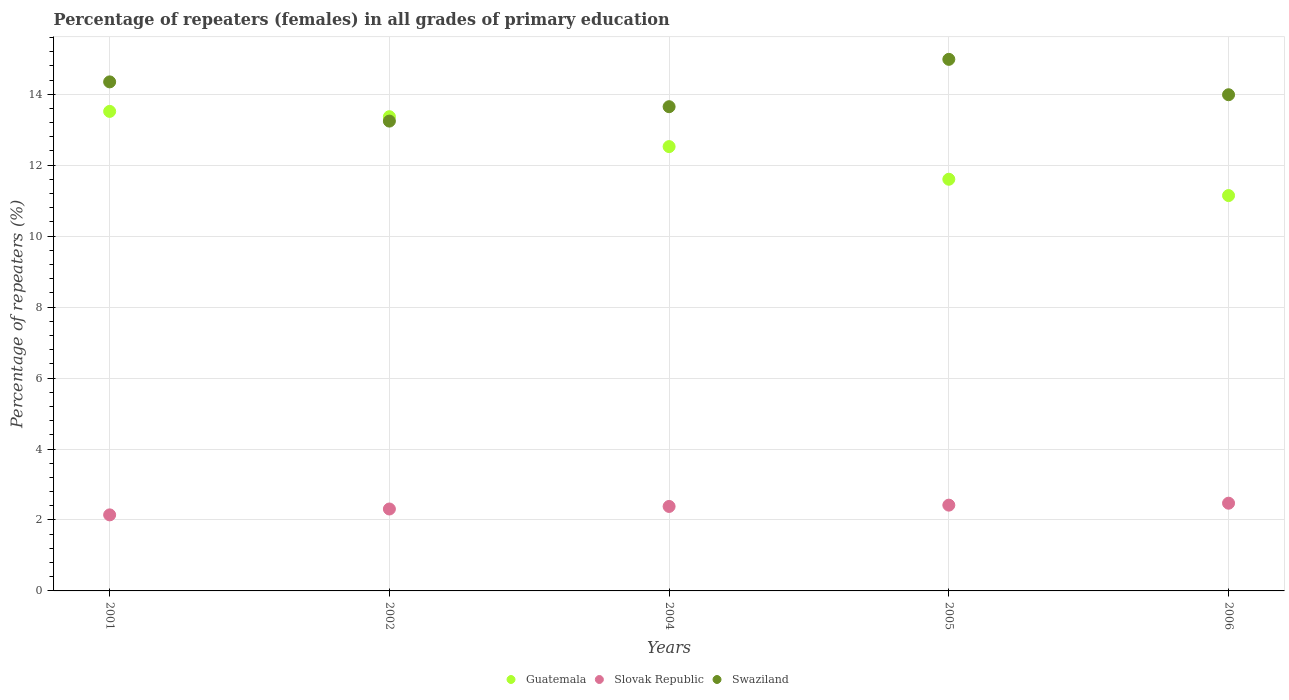How many different coloured dotlines are there?
Your answer should be very brief. 3. Is the number of dotlines equal to the number of legend labels?
Give a very brief answer. Yes. What is the percentage of repeaters (females) in Slovak Republic in 2004?
Provide a short and direct response. 2.38. Across all years, what is the maximum percentage of repeaters (females) in Swaziland?
Ensure brevity in your answer.  14.98. Across all years, what is the minimum percentage of repeaters (females) in Swaziland?
Provide a succinct answer. 13.24. In which year was the percentage of repeaters (females) in Guatemala maximum?
Offer a very short reply. 2001. In which year was the percentage of repeaters (females) in Guatemala minimum?
Make the answer very short. 2006. What is the total percentage of repeaters (females) in Swaziland in the graph?
Give a very brief answer. 70.21. What is the difference between the percentage of repeaters (females) in Swaziland in 2001 and that in 2006?
Offer a very short reply. 0.36. What is the difference between the percentage of repeaters (females) in Swaziland in 2006 and the percentage of repeaters (females) in Guatemala in 2002?
Ensure brevity in your answer.  0.62. What is the average percentage of repeaters (females) in Swaziland per year?
Give a very brief answer. 14.04. In the year 2004, what is the difference between the percentage of repeaters (females) in Swaziland and percentage of repeaters (females) in Slovak Republic?
Offer a terse response. 11.27. In how many years, is the percentage of repeaters (females) in Swaziland greater than 6.4 %?
Make the answer very short. 5. What is the ratio of the percentage of repeaters (females) in Slovak Republic in 2002 to that in 2005?
Give a very brief answer. 0.96. Is the percentage of repeaters (females) in Swaziland in 2002 less than that in 2006?
Your answer should be compact. Yes. What is the difference between the highest and the second highest percentage of repeaters (females) in Slovak Republic?
Provide a short and direct response. 0.05. What is the difference between the highest and the lowest percentage of repeaters (females) in Swaziland?
Offer a terse response. 1.74. In how many years, is the percentage of repeaters (females) in Guatemala greater than the average percentage of repeaters (females) in Guatemala taken over all years?
Offer a very short reply. 3. Is the sum of the percentage of repeaters (females) in Slovak Republic in 2001 and 2004 greater than the maximum percentage of repeaters (females) in Guatemala across all years?
Your answer should be very brief. No. Is the percentage of repeaters (females) in Swaziland strictly less than the percentage of repeaters (females) in Guatemala over the years?
Offer a terse response. No. How many dotlines are there?
Offer a very short reply. 3. How many years are there in the graph?
Provide a short and direct response. 5. What is the difference between two consecutive major ticks on the Y-axis?
Offer a terse response. 2. Does the graph contain any zero values?
Offer a terse response. No. Does the graph contain grids?
Offer a terse response. Yes. What is the title of the graph?
Offer a terse response. Percentage of repeaters (females) in all grades of primary education. What is the label or title of the X-axis?
Give a very brief answer. Years. What is the label or title of the Y-axis?
Offer a terse response. Percentage of repeaters (%). What is the Percentage of repeaters (%) in Guatemala in 2001?
Keep it short and to the point. 13.52. What is the Percentage of repeaters (%) of Slovak Republic in 2001?
Keep it short and to the point. 2.14. What is the Percentage of repeaters (%) in Swaziland in 2001?
Your answer should be very brief. 14.35. What is the Percentage of repeaters (%) of Guatemala in 2002?
Make the answer very short. 13.37. What is the Percentage of repeaters (%) of Slovak Republic in 2002?
Your answer should be compact. 2.31. What is the Percentage of repeaters (%) in Swaziland in 2002?
Offer a very short reply. 13.24. What is the Percentage of repeaters (%) of Guatemala in 2004?
Make the answer very short. 12.52. What is the Percentage of repeaters (%) of Slovak Republic in 2004?
Give a very brief answer. 2.38. What is the Percentage of repeaters (%) of Swaziland in 2004?
Offer a very short reply. 13.65. What is the Percentage of repeaters (%) in Guatemala in 2005?
Make the answer very short. 11.6. What is the Percentage of repeaters (%) in Slovak Republic in 2005?
Provide a short and direct response. 2.42. What is the Percentage of repeaters (%) of Swaziland in 2005?
Keep it short and to the point. 14.98. What is the Percentage of repeaters (%) of Guatemala in 2006?
Make the answer very short. 11.14. What is the Percentage of repeaters (%) of Slovak Republic in 2006?
Keep it short and to the point. 2.47. What is the Percentage of repeaters (%) of Swaziland in 2006?
Give a very brief answer. 13.99. Across all years, what is the maximum Percentage of repeaters (%) of Guatemala?
Your answer should be compact. 13.52. Across all years, what is the maximum Percentage of repeaters (%) of Slovak Republic?
Give a very brief answer. 2.47. Across all years, what is the maximum Percentage of repeaters (%) in Swaziland?
Your answer should be very brief. 14.98. Across all years, what is the minimum Percentage of repeaters (%) of Guatemala?
Your answer should be very brief. 11.14. Across all years, what is the minimum Percentage of repeaters (%) of Slovak Republic?
Offer a very short reply. 2.14. Across all years, what is the minimum Percentage of repeaters (%) of Swaziland?
Your response must be concise. 13.24. What is the total Percentage of repeaters (%) of Guatemala in the graph?
Your answer should be very brief. 62.15. What is the total Percentage of repeaters (%) of Slovak Republic in the graph?
Give a very brief answer. 11.72. What is the total Percentage of repeaters (%) of Swaziland in the graph?
Your response must be concise. 70.21. What is the difference between the Percentage of repeaters (%) in Guatemala in 2001 and that in 2002?
Offer a very short reply. 0.15. What is the difference between the Percentage of repeaters (%) in Slovak Republic in 2001 and that in 2002?
Provide a succinct answer. -0.17. What is the difference between the Percentage of repeaters (%) of Swaziland in 2001 and that in 2002?
Keep it short and to the point. 1.11. What is the difference between the Percentage of repeaters (%) of Guatemala in 2001 and that in 2004?
Your response must be concise. 0.99. What is the difference between the Percentage of repeaters (%) of Slovak Republic in 2001 and that in 2004?
Your answer should be very brief. -0.24. What is the difference between the Percentage of repeaters (%) of Swaziland in 2001 and that in 2004?
Provide a short and direct response. 0.7. What is the difference between the Percentage of repeaters (%) in Guatemala in 2001 and that in 2005?
Offer a terse response. 1.91. What is the difference between the Percentage of repeaters (%) in Slovak Republic in 2001 and that in 2005?
Provide a succinct answer. -0.27. What is the difference between the Percentage of repeaters (%) in Swaziland in 2001 and that in 2005?
Your answer should be compact. -0.63. What is the difference between the Percentage of repeaters (%) in Guatemala in 2001 and that in 2006?
Your answer should be very brief. 2.37. What is the difference between the Percentage of repeaters (%) in Slovak Republic in 2001 and that in 2006?
Offer a terse response. -0.33. What is the difference between the Percentage of repeaters (%) in Swaziland in 2001 and that in 2006?
Your answer should be very brief. 0.36. What is the difference between the Percentage of repeaters (%) of Guatemala in 2002 and that in 2004?
Your response must be concise. 0.84. What is the difference between the Percentage of repeaters (%) of Slovak Republic in 2002 and that in 2004?
Offer a terse response. -0.07. What is the difference between the Percentage of repeaters (%) of Swaziland in 2002 and that in 2004?
Make the answer very short. -0.41. What is the difference between the Percentage of repeaters (%) of Guatemala in 2002 and that in 2005?
Offer a very short reply. 1.76. What is the difference between the Percentage of repeaters (%) of Slovak Republic in 2002 and that in 2005?
Offer a terse response. -0.11. What is the difference between the Percentage of repeaters (%) in Swaziland in 2002 and that in 2005?
Offer a very short reply. -1.74. What is the difference between the Percentage of repeaters (%) of Guatemala in 2002 and that in 2006?
Give a very brief answer. 2.22. What is the difference between the Percentage of repeaters (%) in Slovak Republic in 2002 and that in 2006?
Your answer should be very brief. -0.16. What is the difference between the Percentage of repeaters (%) of Swaziland in 2002 and that in 2006?
Provide a short and direct response. -0.74. What is the difference between the Percentage of repeaters (%) of Guatemala in 2004 and that in 2005?
Keep it short and to the point. 0.92. What is the difference between the Percentage of repeaters (%) in Slovak Republic in 2004 and that in 2005?
Ensure brevity in your answer.  -0.04. What is the difference between the Percentage of repeaters (%) of Swaziland in 2004 and that in 2005?
Give a very brief answer. -1.33. What is the difference between the Percentage of repeaters (%) in Guatemala in 2004 and that in 2006?
Ensure brevity in your answer.  1.38. What is the difference between the Percentage of repeaters (%) of Slovak Republic in 2004 and that in 2006?
Provide a short and direct response. -0.09. What is the difference between the Percentage of repeaters (%) in Swaziland in 2004 and that in 2006?
Make the answer very short. -0.34. What is the difference between the Percentage of repeaters (%) of Guatemala in 2005 and that in 2006?
Ensure brevity in your answer.  0.46. What is the difference between the Percentage of repeaters (%) of Slovak Republic in 2005 and that in 2006?
Your response must be concise. -0.05. What is the difference between the Percentage of repeaters (%) in Guatemala in 2001 and the Percentage of repeaters (%) in Slovak Republic in 2002?
Keep it short and to the point. 11.21. What is the difference between the Percentage of repeaters (%) of Guatemala in 2001 and the Percentage of repeaters (%) of Swaziland in 2002?
Offer a very short reply. 0.27. What is the difference between the Percentage of repeaters (%) in Slovak Republic in 2001 and the Percentage of repeaters (%) in Swaziland in 2002?
Make the answer very short. -11.1. What is the difference between the Percentage of repeaters (%) in Guatemala in 2001 and the Percentage of repeaters (%) in Slovak Republic in 2004?
Your response must be concise. 11.14. What is the difference between the Percentage of repeaters (%) in Guatemala in 2001 and the Percentage of repeaters (%) in Swaziland in 2004?
Offer a very short reply. -0.13. What is the difference between the Percentage of repeaters (%) in Slovak Republic in 2001 and the Percentage of repeaters (%) in Swaziland in 2004?
Ensure brevity in your answer.  -11.51. What is the difference between the Percentage of repeaters (%) in Guatemala in 2001 and the Percentage of repeaters (%) in Slovak Republic in 2005?
Give a very brief answer. 11.1. What is the difference between the Percentage of repeaters (%) of Guatemala in 2001 and the Percentage of repeaters (%) of Swaziland in 2005?
Provide a short and direct response. -1.47. What is the difference between the Percentage of repeaters (%) of Slovak Republic in 2001 and the Percentage of repeaters (%) of Swaziland in 2005?
Your answer should be compact. -12.84. What is the difference between the Percentage of repeaters (%) of Guatemala in 2001 and the Percentage of repeaters (%) of Slovak Republic in 2006?
Make the answer very short. 11.04. What is the difference between the Percentage of repeaters (%) of Guatemala in 2001 and the Percentage of repeaters (%) of Swaziland in 2006?
Offer a very short reply. -0.47. What is the difference between the Percentage of repeaters (%) of Slovak Republic in 2001 and the Percentage of repeaters (%) of Swaziland in 2006?
Provide a short and direct response. -11.84. What is the difference between the Percentage of repeaters (%) in Guatemala in 2002 and the Percentage of repeaters (%) in Slovak Republic in 2004?
Provide a succinct answer. 10.99. What is the difference between the Percentage of repeaters (%) in Guatemala in 2002 and the Percentage of repeaters (%) in Swaziland in 2004?
Provide a succinct answer. -0.28. What is the difference between the Percentage of repeaters (%) in Slovak Republic in 2002 and the Percentage of repeaters (%) in Swaziland in 2004?
Provide a short and direct response. -11.34. What is the difference between the Percentage of repeaters (%) in Guatemala in 2002 and the Percentage of repeaters (%) in Slovak Republic in 2005?
Offer a very short reply. 10.95. What is the difference between the Percentage of repeaters (%) of Guatemala in 2002 and the Percentage of repeaters (%) of Swaziland in 2005?
Make the answer very short. -1.62. What is the difference between the Percentage of repeaters (%) of Slovak Republic in 2002 and the Percentage of repeaters (%) of Swaziland in 2005?
Make the answer very short. -12.67. What is the difference between the Percentage of repeaters (%) in Guatemala in 2002 and the Percentage of repeaters (%) in Slovak Republic in 2006?
Your answer should be compact. 10.89. What is the difference between the Percentage of repeaters (%) in Guatemala in 2002 and the Percentage of repeaters (%) in Swaziland in 2006?
Ensure brevity in your answer.  -0.62. What is the difference between the Percentage of repeaters (%) in Slovak Republic in 2002 and the Percentage of repeaters (%) in Swaziland in 2006?
Your response must be concise. -11.68. What is the difference between the Percentage of repeaters (%) of Guatemala in 2004 and the Percentage of repeaters (%) of Slovak Republic in 2005?
Provide a short and direct response. 10.11. What is the difference between the Percentage of repeaters (%) of Guatemala in 2004 and the Percentage of repeaters (%) of Swaziland in 2005?
Your response must be concise. -2.46. What is the difference between the Percentage of repeaters (%) in Slovak Republic in 2004 and the Percentage of repeaters (%) in Swaziland in 2005?
Provide a short and direct response. -12.6. What is the difference between the Percentage of repeaters (%) in Guatemala in 2004 and the Percentage of repeaters (%) in Slovak Republic in 2006?
Give a very brief answer. 10.05. What is the difference between the Percentage of repeaters (%) of Guatemala in 2004 and the Percentage of repeaters (%) of Swaziland in 2006?
Provide a short and direct response. -1.46. What is the difference between the Percentage of repeaters (%) in Slovak Republic in 2004 and the Percentage of repeaters (%) in Swaziland in 2006?
Provide a short and direct response. -11.6. What is the difference between the Percentage of repeaters (%) of Guatemala in 2005 and the Percentage of repeaters (%) of Slovak Republic in 2006?
Keep it short and to the point. 9.13. What is the difference between the Percentage of repeaters (%) in Guatemala in 2005 and the Percentage of repeaters (%) in Swaziland in 2006?
Provide a short and direct response. -2.38. What is the difference between the Percentage of repeaters (%) of Slovak Republic in 2005 and the Percentage of repeaters (%) of Swaziland in 2006?
Provide a succinct answer. -11.57. What is the average Percentage of repeaters (%) of Guatemala per year?
Provide a succinct answer. 12.43. What is the average Percentage of repeaters (%) of Slovak Republic per year?
Offer a very short reply. 2.34. What is the average Percentage of repeaters (%) in Swaziland per year?
Make the answer very short. 14.04. In the year 2001, what is the difference between the Percentage of repeaters (%) in Guatemala and Percentage of repeaters (%) in Slovak Republic?
Provide a short and direct response. 11.37. In the year 2001, what is the difference between the Percentage of repeaters (%) of Guatemala and Percentage of repeaters (%) of Swaziland?
Offer a very short reply. -0.83. In the year 2001, what is the difference between the Percentage of repeaters (%) in Slovak Republic and Percentage of repeaters (%) in Swaziland?
Offer a terse response. -12.2. In the year 2002, what is the difference between the Percentage of repeaters (%) in Guatemala and Percentage of repeaters (%) in Slovak Republic?
Provide a succinct answer. 11.06. In the year 2002, what is the difference between the Percentage of repeaters (%) of Guatemala and Percentage of repeaters (%) of Swaziland?
Your response must be concise. 0.12. In the year 2002, what is the difference between the Percentage of repeaters (%) of Slovak Republic and Percentage of repeaters (%) of Swaziland?
Your answer should be compact. -10.93. In the year 2004, what is the difference between the Percentage of repeaters (%) of Guatemala and Percentage of repeaters (%) of Slovak Republic?
Give a very brief answer. 10.14. In the year 2004, what is the difference between the Percentage of repeaters (%) in Guatemala and Percentage of repeaters (%) in Swaziland?
Provide a succinct answer. -1.12. In the year 2004, what is the difference between the Percentage of repeaters (%) in Slovak Republic and Percentage of repeaters (%) in Swaziland?
Keep it short and to the point. -11.27. In the year 2005, what is the difference between the Percentage of repeaters (%) in Guatemala and Percentage of repeaters (%) in Slovak Republic?
Provide a succinct answer. 9.19. In the year 2005, what is the difference between the Percentage of repeaters (%) in Guatemala and Percentage of repeaters (%) in Swaziland?
Keep it short and to the point. -3.38. In the year 2005, what is the difference between the Percentage of repeaters (%) of Slovak Republic and Percentage of repeaters (%) of Swaziland?
Ensure brevity in your answer.  -12.57. In the year 2006, what is the difference between the Percentage of repeaters (%) of Guatemala and Percentage of repeaters (%) of Slovak Republic?
Your response must be concise. 8.67. In the year 2006, what is the difference between the Percentage of repeaters (%) of Guatemala and Percentage of repeaters (%) of Swaziland?
Keep it short and to the point. -2.84. In the year 2006, what is the difference between the Percentage of repeaters (%) in Slovak Republic and Percentage of repeaters (%) in Swaziland?
Make the answer very short. -11.51. What is the ratio of the Percentage of repeaters (%) of Guatemala in 2001 to that in 2002?
Your answer should be compact. 1.01. What is the ratio of the Percentage of repeaters (%) of Slovak Republic in 2001 to that in 2002?
Offer a very short reply. 0.93. What is the ratio of the Percentage of repeaters (%) in Swaziland in 2001 to that in 2002?
Keep it short and to the point. 1.08. What is the ratio of the Percentage of repeaters (%) of Guatemala in 2001 to that in 2004?
Give a very brief answer. 1.08. What is the ratio of the Percentage of repeaters (%) of Slovak Republic in 2001 to that in 2004?
Make the answer very short. 0.9. What is the ratio of the Percentage of repeaters (%) in Swaziland in 2001 to that in 2004?
Your answer should be very brief. 1.05. What is the ratio of the Percentage of repeaters (%) in Guatemala in 2001 to that in 2005?
Keep it short and to the point. 1.16. What is the ratio of the Percentage of repeaters (%) in Slovak Republic in 2001 to that in 2005?
Keep it short and to the point. 0.89. What is the ratio of the Percentage of repeaters (%) of Swaziland in 2001 to that in 2005?
Keep it short and to the point. 0.96. What is the ratio of the Percentage of repeaters (%) of Guatemala in 2001 to that in 2006?
Provide a succinct answer. 1.21. What is the ratio of the Percentage of repeaters (%) in Slovak Republic in 2001 to that in 2006?
Your response must be concise. 0.87. What is the ratio of the Percentage of repeaters (%) of Swaziland in 2001 to that in 2006?
Your answer should be very brief. 1.03. What is the ratio of the Percentage of repeaters (%) of Guatemala in 2002 to that in 2004?
Give a very brief answer. 1.07. What is the ratio of the Percentage of repeaters (%) of Slovak Republic in 2002 to that in 2004?
Give a very brief answer. 0.97. What is the ratio of the Percentage of repeaters (%) in Swaziland in 2002 to that in 2004?
Your answer should be very brief. 0.97. What is the ratio of the Percentage of repeaters (%) in Guatemala in 2002 to that in 2005?
Provide a short and direct response. 1.15. What is the ratio of the Percentage of repeaters (%) of Slovak Republic in 2002 to that in 2005?
Give a very brief answer. 0.96. What is the ratio of the Percentage of repeaters (%) in Swaziland in 2002 to that in 2005?
Keep it short and to the point. 0.88. What is the ratio of the Percentage of repeaters (%) in Guatemala in 2002 to that in 2006?
Ensure brevity in your answer.  1.2. What is the ratio of the Percentage of repeaters (%) of Slovak Republic in 2002 to that in 2006?
Make the answer very short. 0.93. What is the ratio of the Percentage of repeaters (%) in Swaziland in 2002 to that in 2006?
Your answer should be very brief. 0.95. What is the ratio of the Percentage of repeaters (%) in Guatemala in 2004 to that in 2005?
Provide a short and direct response. 1.08. What is the ratio of the Percentage of repeaters (%) of Slovak Republic in 2004 to that in 2005?
Your answer should be very brief. 0.98. What is the ratio of the Percentage of repeaters (%) in Swaziland in 2004 to that in 2005?
Make the answer very short. 0.91. What is the ratio of the Percentage of repeaters (%) in Guatemala in 2004 to that in 2006?
Ensure brevity in your answer.  1.12. What is the ratio of the Percentage of repeaters (%) in Slovak Republic in 2004 to that in 2006?
Make the answer very short. 0.96. What is the ratio of the Percentage of repeaters (%) of Swaziland in 2004 to that in 2006?
Make the answer very short. 0.98. What is the ratio of the Percentage of repeaters (%) in Guatemala in 2005 to that in 2006?
Your response must be concise. 1.04. What is the ratio of the Percentage of repeaters (%) of Slovak Republic in 2005 to that in 2006?
Your answer should be compact. 0.98. What is the ratio of the Percentage of repeaters (%) in Swaziland in 2005 to that in 2006?
Offer a terse response. 1.07. What is the difference between the highest and the second highest Percentage of repeaters (%) of Guatemala?
Provide a short and direct response. 0.15. What is the difference between the highest and the second highest Percentage of repeaters (%) in Slovak Republic?
Provide a short and direct response. 0.05. What is the difference between the highest and the second highest Percentage of repeaters (%) of Swaziland?
Provide a succinct answer. 0.63. What is the difference between the highest and the lowest Percentage of repeaters (%) of Guatemala?
Your response must be concise. 2.37. What is the difference between the highest and the lowest Percentage of repeaters (%) in Slovak Republic?
Give a very brief answer. 0.33. What is the difference between the highest and the lowest Percentage of repeaters (%) of Swaziland?
Your response must be concise. 1.74. 